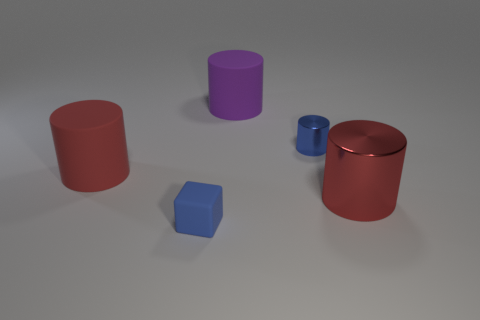Is there anything else that is the same shape as the blue rubber object?
Make the answer very short. No. The large object that is behind the blue thing that is behind the large cylinder that is right of the small blue metallic cylinder is made of what material?
Your answer should be compact. Rubber. What number of other objects are the same size as the cube?
Your answer should be compact. 1. What is the size of the matte object that is the same color as the tiny cylinder?
Provide a succinct answer. Small. Is the number of cylinders that are behind the big red rubber cylinder greater than the number of small blue metallic things?
Give a very brief answer. Yes. Are there any tiny cylinders that have the same color as the block?
Your response must be concise. Yes. The object that is the same size as the blue block is what color?
Offer a very short reply. Blue. There is a big red thing that is on the left side of the tiny cube; how many blue things are behind it?
Offer a very short reply. 1. How many objects are either rubber objects on the left side of the blue matte block or blue rubber cubes?
Keep it short and to the point. 2. What number of blue objects have the same material as the purple cylinder?
Ensure brevity in your answer.  1. 